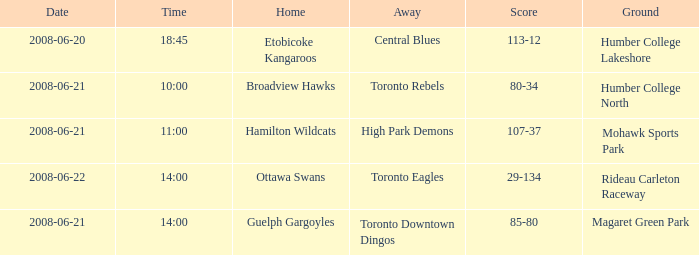What is the ground with a date that is 2008-06-20? Humber College Lakeshore. 